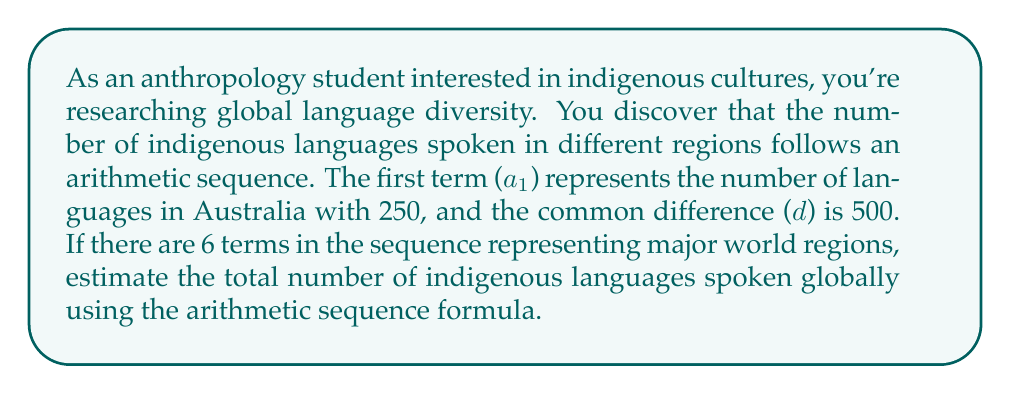Can you answer this question? Let's approach this step-by-step:

1) We're given an arithmetic sequence with:
   - First term (a₁) = 250
   - Common difference (d) = 500
   - Number of terms (n) = 6

2) The formula for the sum of an arithmetic sequence is:

   $$S_n = \frac{n}{2}(a_1 + a_n)$$

   Where $a_n$ is the last term.

3) To find $a_n$, we use the formula:

   $$a_n = a_1 + (n-1)d$$

4) Let's calculate $a_6$:

   $$a_6 = 250 + (6-1)500 = 250 + 2500 = 2750$$

5) Now we can use the sum formula:

   $$S_6 = \frac{6}{2}(250 + 2750)$$

6) Simplify:

   $$S_6 = 3(3000) = 9000$$

Therefore, the estimated total number of indigenous languages is 9000.
Answer: 9000 languages 